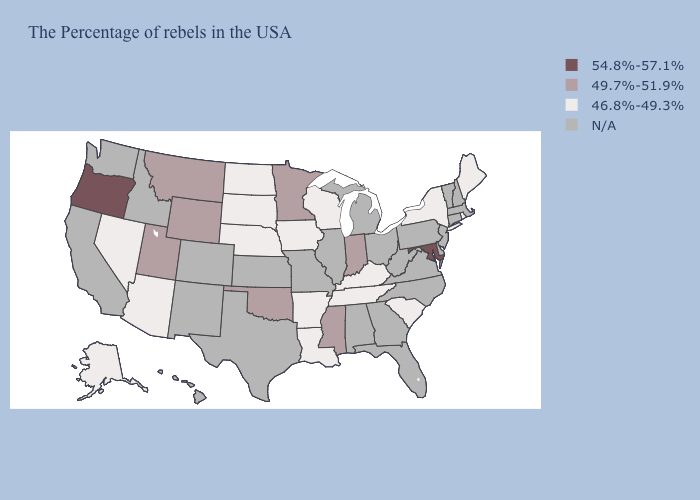What is the value of Louisiana?
Quick response, please. 46.8%-49.3%. What is the highest value in the West ?
Write a very short answer. 54.8%-57.1%. Name the states that have a value in the range N/A?
Answer briefly. Massachusetts, New Hampshire, Vermont, Connecticut, New Jersey, Delaware, Pennsylvania, Virginia, North Carolina, West Virginia, Ohio, Florida, Georgia, Michigan, Alabama, Illinois, Missouri, Kansas, Texas, Colorado, New Mexico, Idaho, California, Washington, Hawaii. What is the lowest value in the USA?
Be succinct. 46.8%-49.3%. What is the value of Alaska?
Keep it brief. 46.8%-49.3%. Does the first symbol in the legend represent the smallest category?
Give a very brief answer. No. Name the states that have a value in the range 46.8%-49.3%?
Quick response, please. Maine, Rhode Island, New York, South Carolina, Kentucky, Tennessee, Wisconsin, Louisiana, Arkansas, Iowa, Nebraska, South Dakota, North Dakota, Arizona, Nevada, Alaska. Name the states that have a value in the range 46.8%-49.3%?
Give a very brief answer. Maine, Rhode Island, New York, South Carolina, Kentucky, Tennessee, Wisconsin, Louisiana, Arkansas, Iowa, Nebraska, South Dakota, North Dakota, Arizona, Nevada, Alaska. What is the highest value in the USA?
Answer briefly. 54.8%-57.1%. Does Maryland have the highest value in the South?
Quick response, please. Yes. Among the states that border Wyoming , which have the highest value?
Write a very short answer. Utah, Montana. What is the lowest value in the USA?
Concise answer only. 46.8%-49.3%. Is the legend a continuous bar?
Concise answer only. No. 